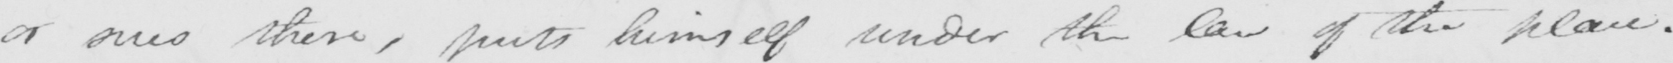Can you read and transcribe this handwriting? or ones there , puts himself under the law of the place . 